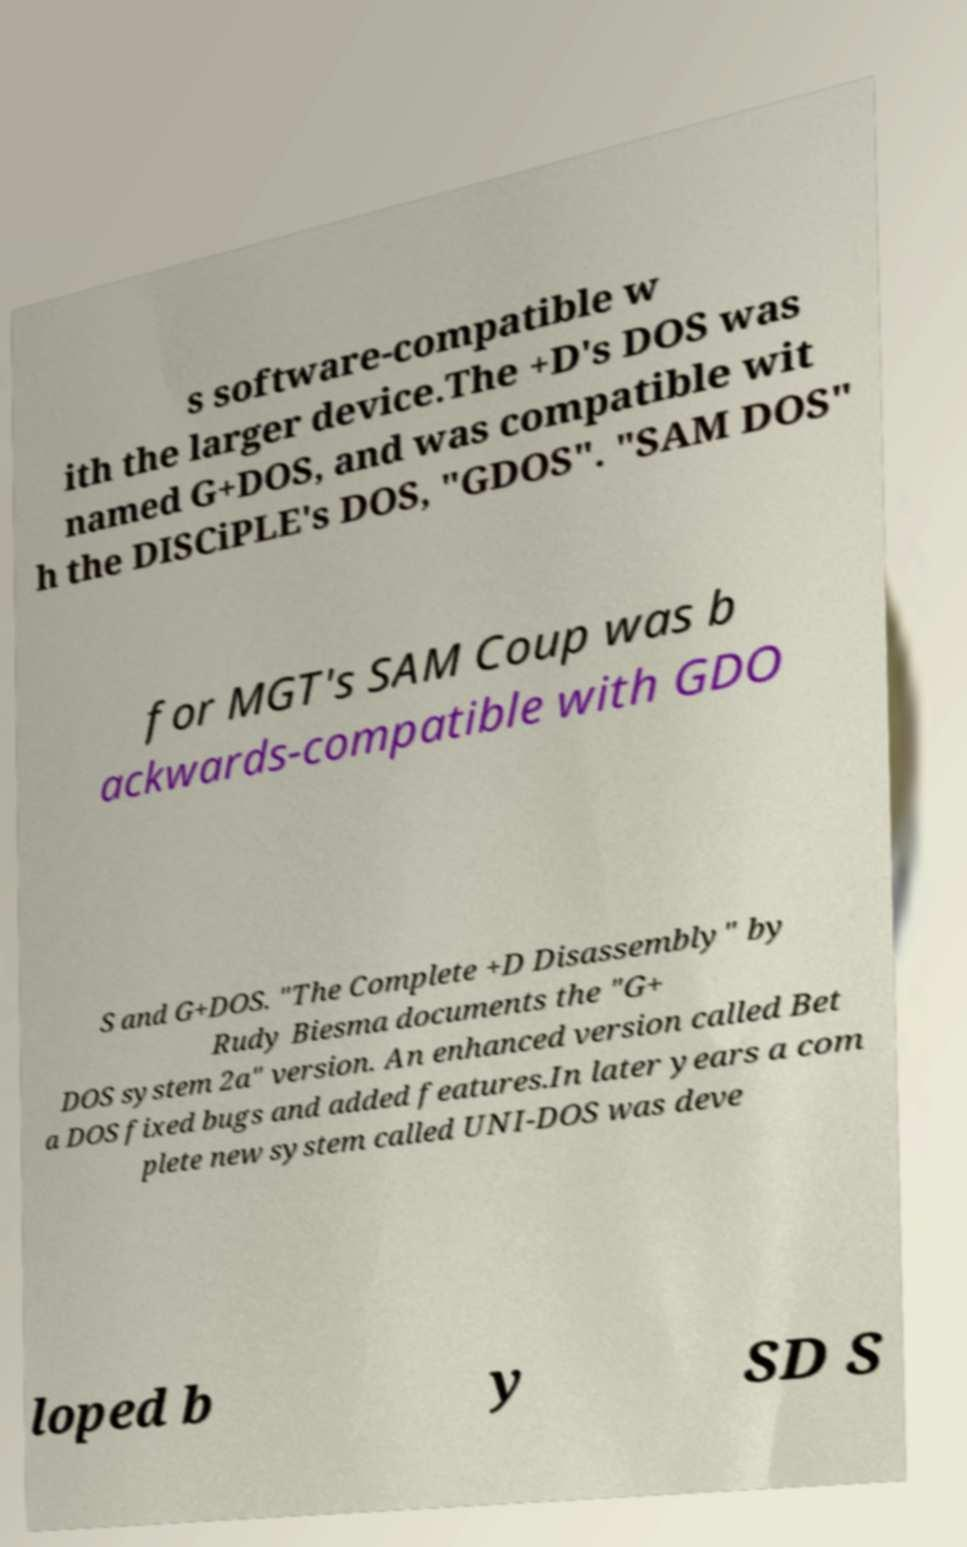What messages or text are displayed in this image? I need them in a readable, typed format. s software-compatible w ith the larger device.The +D's DOS was named G+DOS, and was compatible wit h the DISCiPLE's DOS, "GDOS". "SAM DOS" for MGT's SAM Coup was b ackwards-compatible with GDO S and G+DOS. "The Complete +D Disassembly" by Rudy Biesma documents the "G+ DOS system 2a" version. An enhanced version called Bet a DOS fixed bugs and added features.In later years a com plete new system called UNI-DOS was deve loped b y SD S 